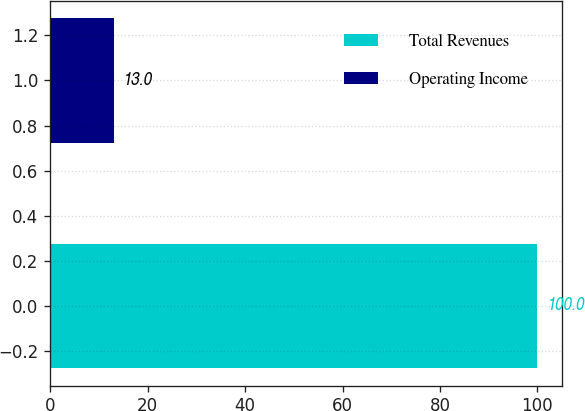Convert chart. <chart><loc_0><loc_0><loc_500><loc_500><bar_chart><fcel>Total Revenues<fcel>Operating Income<nl><fcel>100<fcel>13<nl></chart> 